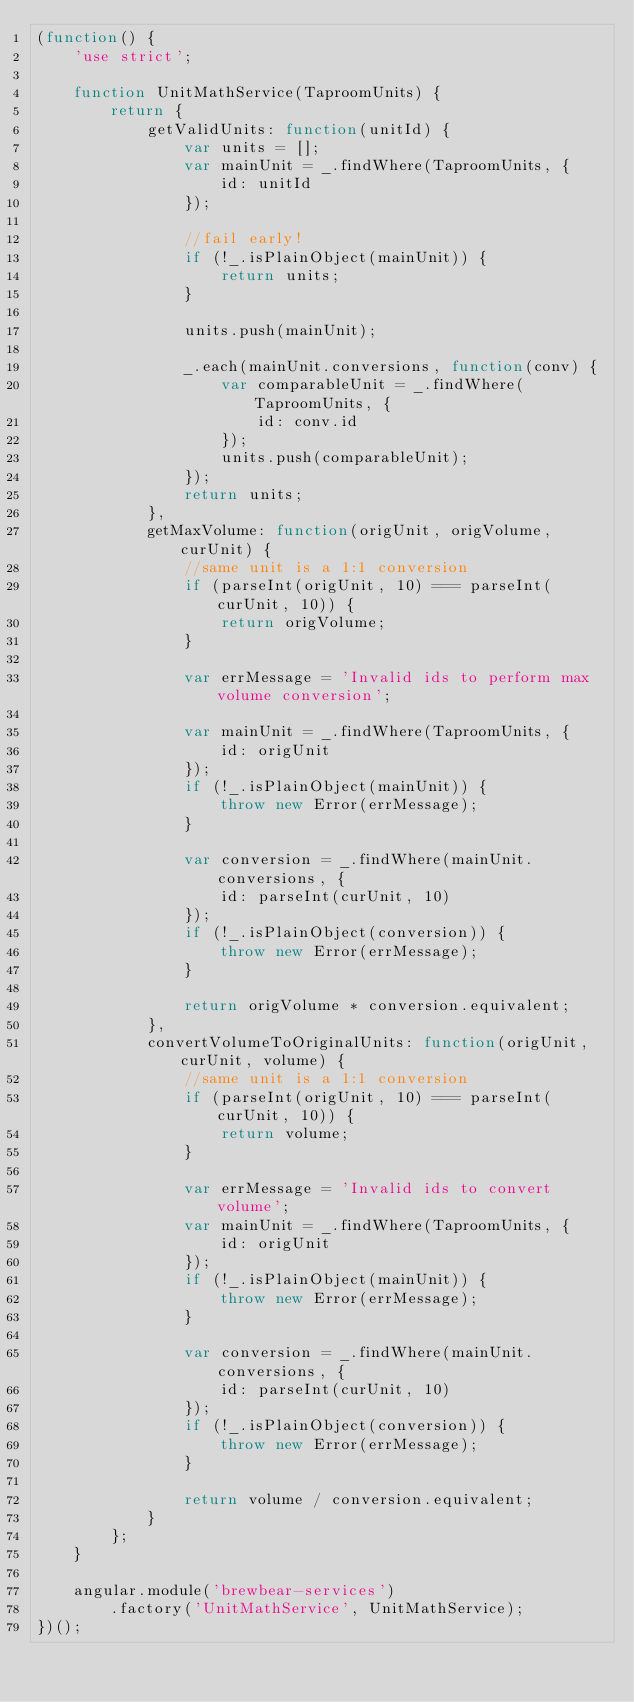Convert code to text. <code><loc_0><loc_0><loc_500><loc_500><_JavaScript_>(function() {
    'use strict';

    function UnitMathService(TaproomUnits) {
        return {
            getValidUnits: function(unitId) {
                var units = [];
                var mainUnit = _.findWhere(TaproomUnits, {
                    id: unitId
                });

                //fail early!
                if (!_.isPlainObject(mainUnit)) {
                    return units;
                }

                units.push(mainUnit);

                _.each(mainUnit.conversions, function(conv) {
                    var comparableUnit = _.findWhere(TaproomUnits, {
                        id: conv.id
                    });
                    units.push(comparableUnit);
                });
                return units;
            },
            getMaxVolume: function(origUnit, origVolume, curUnit) {
                //same unit is a 1:1 conversion
                if (parseInt(origUnit, 10) === parseInt(curUnit, 10)) {
                    return origVolume;
                }

                var errMessage = 'Invalid ids to perform max volume conversion';

                var mainUnit = _.findWhere(TaproomUnits, {
                    id: origUnit
                });
                if (!_.isPlainObject(mainUnit)) {
                    throw new Error(errMessage);
                }

                var conversion = _.findWhere(mainUnit.conversions, {
                    id: parseInt(curUnit, 10)
                });
                if (!_.isPlainObject(conversion)) {
                    throw new Error(errMessage);
                }

                return origVolume * conversion.equivalent;
            },
            convertVolumeToOriginalUnits: function(origUnit, curUnit, volume) {
                //same unit is a 1:1 conversion
                if (parseInt(origUnit, 10) === parseInt(curUnit, 10)) {
                    return volume;
                }

                var errMessage = 'Invalid ids to convert volume';
                var mainUnit = _.findWhere(TaproomUnits, {
                    id: origUnit
                });
                if (!_.isPlainObject(mainUnit)) {
                    throw new Error(errMessage);
                }

                var conversion = _.findWhere(mainUnit.conversions, {
                    id: parseInt(curUnit, 10)
                });
                if (!_.isPlainObject(conversion)) {
                    throw new Error(errMessage);
                }

                return volume / conversion.equivalent;
            }
        };
    }

    angular.module('brewbear-services')
        .factory('UnitMathService', UnitMathService);
})();
</code> 